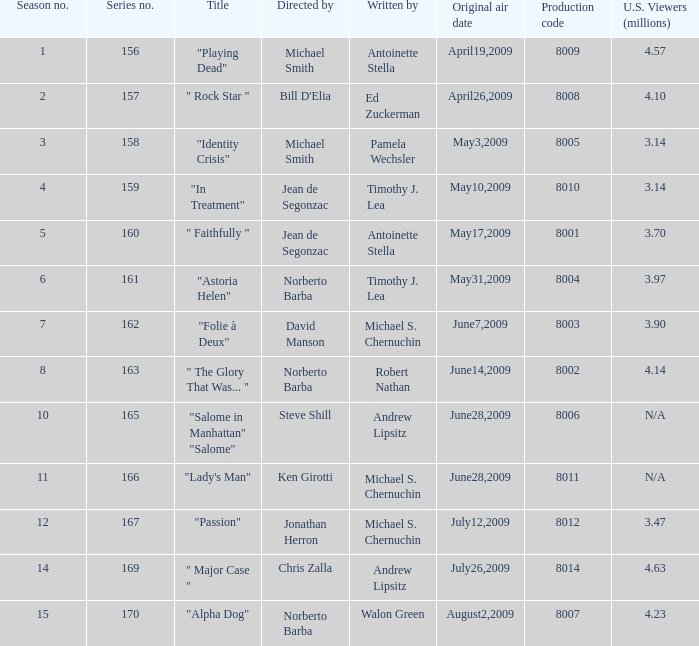Who is the author of the series episode number 170? Walon Green. 